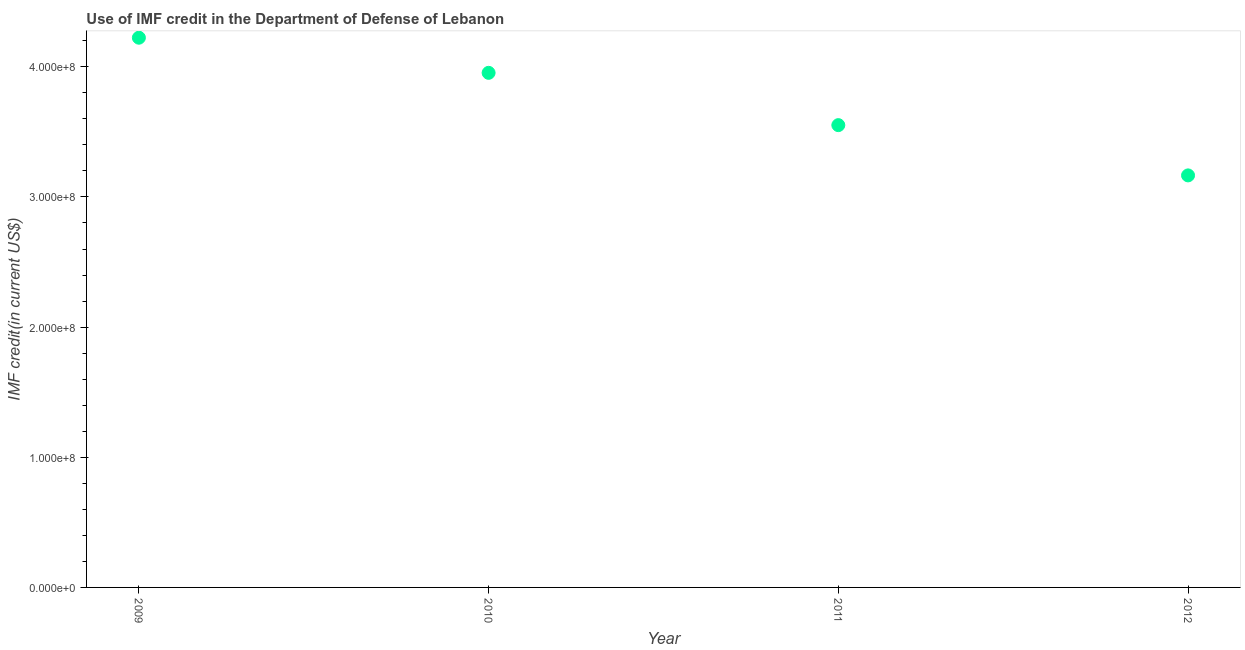What is the use of imf credit in dod in 2009?
Ensure brevity in your answer.  4.22e+08. Across all years, what is the maximum use of imf credit in dod?
Ensure brevity in your answer.  4.22e+08. Across all years, what is the minimum use of imf credit in dod?
Ensure brevity in your answer.  3.17e+08. In which year was the use of imf credit in dod maximum?
Your answer should be compact. 2009. In which year was the use of imf credit in dod minimum?
Give a very brief answer. 2012. What is the sum of the use of imf credit in dod?
Your answer should be compact. 1.49e+09. What is the difference between the use of imf credit in dod in 2009 and 2012?
Keep it short and to the point. 1.06e+08. What is the average use of imf credit in dod per year?
Keep it short and to the point. 3.72e+08. What is the median use of imf credit in dod?
Your answer should be compact. 3.75e+08. What is the ratio of the use of imf credit in dod in 2010 to that in 2011?
Offer a terse response. 1.11. Is the use of imf credit in dod in 2011 less than that in 2012?
Your response must be concise. No. What is the difference between the highest and the second highest use of imf credit in dod?
Provide a succinct answer. 2.70e+07. Is the sum of the use of imf credit in dod in 2009 and 2011 greater than the maximum use of imf credit in dod across all years?
Provide a short and direct response. Yes. What is the difference between the highest and the lowest use of imf credit in dod?
Your answer should be very brief. 1.06e+08. In how many years, is the use of imf credit in dod greater than the average use of imf credit in dod taken over all years?
Give a very brief answer. 2. How many dotlines are there?
Offer a very short reply. 1. Are the values on the major ticks of Y-axis written in scientific E-notation?
Offer a terse response. Yes. Does the graph contain any zero values?
Keep it short and to the point. No. Does the graph contain grids?
Ensure brevity in your answer.  No. What is the title of the graph?
Provide a succinct answer. Use of IMF credit in the Department of Defense of Lebanon. What is the label or title of the Y-axis?
Keep it short and to the point. IMF credit(in current US$). What is the IMF credit(in current US$) in 2009?
Your answer should be very brief. 4.22e+08. What is the IMF credit(in current US$) in 2010?
Ensure brevity in your answer.  3.95e+08. What is the IMF credit(in current US$) in 2011?
Provide a short and direct response. 3.55e+08. What is the IMF credit(in current US$) in 2012?
Provide a succinct answer. 3.17e+08. What is the difference between the IMF credit(in current US$) in 2009 and 2010?
Your response must be concise. 2.70e+07. What is the difference between the IMF credit(in current US$) in 2009 and 2011?
Give a very brief answer. 6.72e+07. What is the difference between the IMF credit(in current US$) in 2009 and 2012?
Keep it short and to the point. 1.06e+08. What is the difference between the IMF credit(in current US$) in 2010 and 2011?
Provide a short and direct response. 4.02e+07. What is the difference between the IMF credit(in current US$) in 2010 and 2012?
Offer a terse response. 7.88e+07. What is the difference between the IMF credit(in current US$) in 2011 and 2012?
Provide a succinct answer. 3.86e+07. What is the ratio of the IMF credit(in current US$) in 2009 to that in 2010?
Give a very brief answer. 1.07. What is the ratio of the IMF credit(in current US$) in 2009 to that in 2011?
Your answer should be compact. 1.19. What is the ratio of the IMF credit(in current US$) in 2009 to that in 2012?
Your response must be concise. 1.33. What is the ratio of the IMF credit(in current US$) in 2010 to that in 2011?
Offer a terse response. 1.11. What is the ratio of the IMF credit(in current US$) in 2010 to that in 2012?
Your answer should be compact. 1.25. What is the ratio of the IMF credit(in current US$) in 2011 to that in 2012?
Offer a terse response. 1.12. 